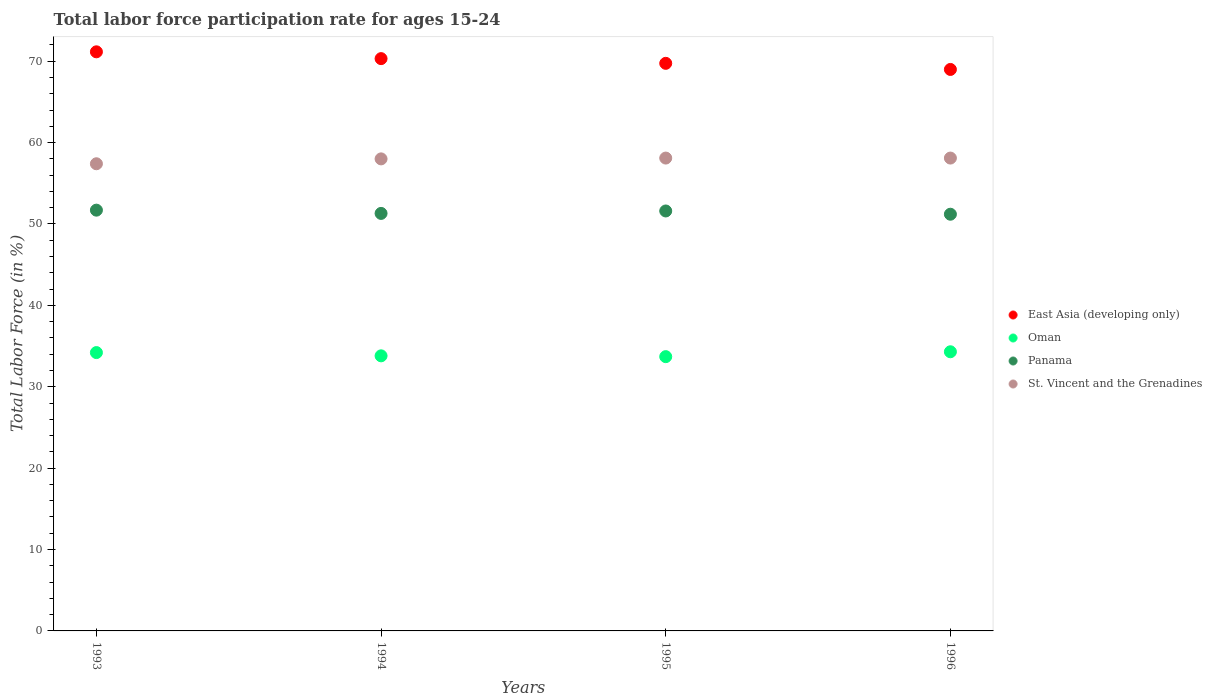Is the number of dotlines equal to the number of legend labels?
Give a very brief answer. Yes. What is the labor force participation rate in St. Vincent and the Grenadines in 1995?
Provide a short and direct response. 58.1. Across all years, what is the maximum labor force participation rate in Panama?
Make the answer very short. 51.7. Across all years, what is the minimum labor force participation rate in East Asia (developing only)?
Provide a succinct answer. 68.99. In which year was the labor force participation rate in Panama minimum?
Keep it short and to the point. 1996. What is the total labor force participation rate in East Asia (developing only) in the graph?
Make the answer very short. 280.2. What is the difference between the labor force participation rate in East Asia (developing only) in 1995 and that in 1996?
Provide a short and direct response. 0.75. What is the difference between the labor force participation rate in Panama in 1993 and the labor force participation rate in East Asia (developing only) in 1994?
Your answer should be compact. -18.62. What is the average labor force participation rate in St. Vincent and the Grenadines per year?
Your response must be concise. 57.9. In the year 1993, what is the difference between the labor force participation rate in East Asia (developing only) and labor force participation rate in Panama?
Your answer should be compact. 19.46. What is the ratio of the labor force participation rate in Panama in 1993 to that in 1996?
Offer a very short reply. 1.01. Is the difference between the labor force participation rate in East Asia (developing only) in 1995 and 1996 greater than the difference between the labor force participation rate in Panama in 1995 and 1996?
Provide a succinct answer. Yes. What is the difference between the highest and the second highest labor force participation rate in Oman?
Provide a short and direct response. 0.1. What is the difference between the highest and the lowest labor force participation rate in East Asia (developing only)?
Your answer should be very brief. 2.17. In how many years, is the labor force participation rate in East Asia (developing only) greater than the average labor force participation rate in East Asia (developing only) taken over all years?
Provide a succinct answer. 2. Is it the case that in every year, the sum of the labor force participation rate in Panama and labor force participation rate in Oman  is greater than the labor force participation rate in East Asia (developing only)?
Offer a terse response. Yes. Does the labor force participation rate in Oman monotonically increase over the years?
Offer a very short reply. No. How many years are there in the graph?
Your answer should be compact. 4. Are the values on the major ticks of Y-axis written in scientific E-notation?
Ensure brevity in your answer.  No. Does the graph contain any zero values?
Make the answer very short. No. Does the graph contain grids?
Provide a succinct answer. No. Where does the legend appear in the graph?
Keep it short and to the point. Center right. What is the title of the graph?
Offer a very short reply. Total labor force participation rate for ages 15-24. Does "Djibouti" appear as one of the legend labels in the graph?
Your answer should be compact. No. What is the label or title of the X-axis?
Your answer should be compact. Years. What is the Total Labor Force (in %) of East Asia (developing only) in 1993?
Provide a short and direct response. 71.16. What is the Total Labor Force (in %) of Oman in 1993?
Provide a short and direct response. 34.2. What is the Total Labor Force (in %) of Panama in 1993?
Provide a succinct answer. 51.7. What is the Total Labor Force (in %) in St. Vincent and the Grenadines in 1993?
Your answer should be very brief. 57.4. What is the Total Labor Force (in %) in East Asia (developing only) in 1994?
Your answer should be very brief. 70.32. What is the Total Labor Force (in %) of Oman in 1994?
Keep it short and to the point. 33.8. What is the Total Labor Force (in %) in Panama in 1994?
Your answer should be compact. 51.3. What is the Total Labor Force (in %) of St. Vincent and the Grenadines in 1994?
Your response must be concise. 58. What is the Total Labor Force (in %) of East Asia (developing only) in 1995?
Offer a very short reply. 69.74. What is the Total Labor Force (in %) of Oman in 1995?
Give a very brief answer. 33.7. What is the Total Labor Force (in %) of Panama in 1995?
Your response must be concise. 51.6. What is the Total Labor Force (in %) of St. Vincent and the Grenadines in 1995?
Provide a succinct answer. 58.1. What is the Total Labor Force (in %) of East Asia (developing only) in 1996?
Your response must be concise. 68.99. What is the Total Labor Force (in %) in Oman in 1996?
Offer a terse response. 34.3. What is the Total Labor Force (in %) in Panama in 1996?
Ensure brevity in your answer.  51.2. What is the Total Labor Force (in %) of St. Vincent and the Grenadines in 1996?
Make the answer very short. 58.1. Across all years, what is the maximum Total Labor Force (in %) of East Asia (developing only)?
Make the answer very short. 71.16. Across all years, what is the maximum Total Labor Force (in %) of Oman?
Offer a terse response. 34.3. Across all years, what is the maximum Total Labor Force (in %) of Panama?
Offer a very short reply. 51.7. Across all years, what is the maximum Total Labor Force (in %) in St. Vincent and the Grenadines?
Ensure brevity in your answer.  58.1. Across all years, what is the minimum Total Labor Force (in %) of East Asia (developing only)?
Provide a short and direct response. 68.99. Across all years, what is the minimum Total Labor Force (in %) of Oman?
Your answer should be very brief. 33.7. Across all years, what is the minimum Total Labor Force (in %) in Panama?
Your answer should be very brief. 51.2. Across all years, what is the minimum Total Labor Force (in %) of St. Vincent and the Grenadines?
Provide a short and direct response. 57.4. What is the total Total Labor Force (in %) of East Asia (developing only) in the graph?
Provide a short and direct response. 280.2. What is the total Total Labor Force (in %) in Oman in the graph?
Your answer should be very brief. 136. What is the total Total Labor Force (in %) of Panama in the graph?
Make the answer very short. 205.8. What is the total Total Labor Force (in %) of St. Vincent and the Grenadines in the graph?
Your answer should be compact. 231.6. What is the difference between the Total Labor Force (in %) of East Asia (developing only) in 1993 and that in 1994?
Offer a terse response. 0.84. What is the difference between the Total Labor Force (in %) of Oman in 1993 and that in 1994?
Provide a succinct answer. 0.4. What is the difference between the Total Labor Force (in %) in St. Vincent and the Grenadines in 1993 and that in 1994?
Your response must be concise. -0.6. What is the difference between the Total Labor Force (in %) of East Asia (developing only) in 1993 and that in 1995?
Provide a succinct answer. 1.42. What is the difference between the Total Labor Force (in %) in Oman in 1993 and that in 1995?
Make the answer very short. 0.5. What is the difference between the Total Labor Force (in %) in Panama in 1993 and that in 1995?
Offer a terse response. 0.1. What is the difference between the Total Labor Force (in %) of East Asia (developing only) in 1993 and that in 1996?
Keep it short and to the point. 2.17. What is the difference between the Total Labor Force (in %) of Panama in 1993 and that in 1996?
Your answer should be very brief. 0.5. What is the difference between the Total Labor Force (in %) in East Asia (developing only) in 1994 and that in 1995?
Provide a succinct answer. 0.58. What is the difference between the Total Labor Force (in %) of Panama in 1994 and that in 1995?
Your answer should be compact. -0.3. What is the difference between the Total Labor Force (in %) in St. Vincent and the Grenadines in 1994 and that in 1995?
Provide a short and direct response. -0.1. What is the difference between the Total Labor Force (in %) of East Asia (developing only) in 1994 and that in 1996?
Make the answer very short. 1.33. What is the difference between the Total Labor Force (in %) of Panama in 1994 and that in 1996?
Ensure brevity in your answer.  0.1. What is the difference between the Total Labor Force (in %) of St. Vincent and the Grenadines in 1994 and that in 1996?
Offer a terse response. -0.1. What is the difference between the Total Labor Force (in %) of East Asia (developing only) in 1995 and that in 1996?
Make the answer very short. 0.75. What is the difference between the Total Labor Force (in %) in Oman in 1995 and that in 1996?
Keep it short and to the point. -0.6. What is the difference between the Total Labor Force (in %) of East Asia (developing only) in 1993 and the Total Labor Force (in %) of Oman in 1994?
Provide a succinct answer. 37.36. What is the difference between the Total Labor Force (in %) of East Asia (developing only) in 1993 and the Total Labor Force (in %) of Panama in 1994?
Keep it short and to the point. 19.86. What is the difference between the Total Labor Force (in %) in East Asia (developing only) in 1993 and the Total Labor Force (in %) in St. Vincent and the Grenadines in 1994?
Your answer should be very brief. 13.16. What is the difference between the Total Labor Force (in %) of Oman in 1993 and the Total Labor Force (in %) of Panama in 1994?
Your answer should be compact. -17.1. What is the difference between the Total Labor Force (in %) of Oman in 1993 and the Total Labor Force (in %) of St. Vincent and the Grenadines in 1994?
Make the answer very short. -23.8. What is the difference between the Total Labor Force (in %) of Panama in 1993 and the Total Labor Force (in %) of St. Vincent and the Grenadines in 1994?
Ensure brevity in your answer.  -6.3. What is the difference between the Total Labor Force (in %) of East Asia (developing only) in 1993 and the Total Labor Force (in %) of Oman in 1995?
Your response must be concise. 37.46. What is the difference between the Total Labor Force (in %) of East Asia (developing only) in 1993 and the Total Labor Force (in %) of Panama in 1995?
Give a very brief answer. 19.56. What is the difference between the Total Labor Force (in %) in East Asia (developing only) in 1993 and the Total Labor Force (in %) in St. Vincent and the Grenadines in 1995?
Offer a very short reply. 13.06. What is the difference between the Total Labor Force (in %) in Oman in 1993 and the Total Labor Force (in %) in Panama in 1995?
Provide a short and direct response. -17.4. What is the difference between the Total Labor Force (in %) in Oman in 1993 and the Total Labor Force (in %) in St. Vincent and the Grenadines in 1995?
Provide a short and direct response. -23.9. What is the difference between the Total Labor Force (in %) of East Asia (developing only) in 1993 and the Total Labor Force (in %) of Oman in 1996?
Offer a very short reply. 36.86. What is the difference between the Total Labor Force (in %) in East Asia (developing only) in 1993 and the Total Labor Force (in %) in Panama in 1996?
Your response must be concise. 19.96. What is the difference between the Total Labor Force (in %) in East Asia (developing only) in 1993 and the Total Labor Force (in %) in St. Vincent and the Grenadines in 1996?
Offer a terse response. 13.06. What is the difference between the Total Labor Force (in %) in Oman in 1993 and the Total Labor Force (in %) in St. Vincent and the Grenadines in 1996?
Make the answer very short. -23.9. What is the difference between the Total Labor Force (in %) of East Asia (developing only) in 1994 and the Total Labor Force (in %) of Oman in 1995?
Keep it short and to the point. 36.62. What is the difference between the Total Labor Force (in %) of East Asia (developing only) in 1994 and the Total Labor Force (in %) of Panama in 1995?
Give a very brief answer. 18.72. What is the difference between the Total Labor Force (in %) in East Asia (developing only) in 1994 and the Total Labor Force (in %) in St. Vincent and the Grenadines in 1995?
Your response must be concise. 12.22. What is the difference between the Total Labor Force (in %) in Oman in 1994 and the Total Labor Force (in %) in Panama in 1995?
Make the answer very short. -17.8. What is the difference between the Total Labor Force (in %) of Oman in 1994 and the Total Labor Force (in %) of St. Vincent and the Grenadines in 1995?
Give a very brief answer. -24.3. What is the difference between the Total Labor Force (in %) of Panama in 1994 and the Total Labor Force (in %) of St. Vincent and the Grenadines in 1995?
Provide a succinct answer. -6.8. What is the difference between the Total Labor Force (in %) of East Asia (developing only) in 1994 and the Total Labor Force (in %) of Oman in 1996?
Keep it short and to the point. 36.02. What is the difference between the Total Labor Force (in %) in East Asia (developing only) in 1994 and the Total Labor Force (in %) in Panama in 1996?
Your response must be concise. 19.12. What is the difference between the Total Labor Force (in %) in East Asia (developing only) in 1994 and the Total Labor Force (in %) in St. Vincent and the Grenadines in 1996?
Your answer should be compact. 12.22. What is the difference between the Total Labor Force (in %) in Oman in 1994 and the Total Labor Force (in %) in Panama in 1996?
Your answer should be compact. -17.4. What is the difference between the Total Labor Force (in %) in Oman in 1994 and the Total Labor Force (in %) in St. Vincent and the Grenadines in 1996?
Offer a terse response. -24.3. What is the difference between the Total Labor Force (in %) in Panama in 1994 and the Total Labor Force (in %) in St. Vincent and the Grenadines in 1996?
Provide a short and direct response. -6.8. What is the difference between the Total Labor Force (in %) in East Asia (developing only) in 1995 and the Total Labor Force (in %) in Oman in 1996?
Make the answer very short. 35.44. What is the difference between the Total Labor Force (in %) of East Asia (developing only) in 1995 and the Total Labor Force (in %) of Panama in 1996?
Your response must be concise. 18.54. What is the difference between the Total Labor Force (in %) of East Asia (developing only) in 1995 and the Total Labor Force (in %) of St. Vincent and the Grenadines in 1996?
Make the answer very short. 11.64. What is the difference between the Total Labor Force (in %) of Oman in 1995 and the Total Labor Force (in %) of Panama in 1996?
Your response must be concise. -17.5. What is the difference between the Total Labor Force (in %) of Oman in 1995 and the Total Labor Force (in %) of St. Vincent and the Grenadines in 1996?
Make the answer very short. -24.4. What is the average Total Labor Force (in %) in East Asia (developing only) per year?
Ensure brevity in your answer.  70.05. What is the average Total Labor Force (in %) in Oman per year?
Provide a succinct answer. 34. What is the average Total Labor Force (in %) of Panama per year?
Keep it short and to the point. 51.45. What is the average Total Labor Force (in %) in St. Vincent and the Grenadines per year?
Provide a succinct answer. 57.9. In the year 1993, what is the difference between the Total Labor Force (in %) in East Asia (developing only) and Total Labor Force (in %) in Oman?
Your answer should be very brief. 36.96. In the year 1993, what is the difference between the Total Labor Force (in %) of East Asia (developing only) and Total Labor Force (in %) of Panama?
Offer a terse response. 19.46. In the year 1993, what is the difference between the Total Labor Force (in %) in East Asia (developing only) and Total Labor Force (in %) in St. Vincent and the Grenadines?
Your answer should be very brief. 13.76. In the year 1993, what is the difference between the Total Labor Force (in %) of Oman and Total Labor Force (in %) of Panama?
Ensure brevity in your answer.  -17.5. In the year 1993, what is the difference between the Total Labor Force (in %) in Oman and Total Labor Force (in %) in St. Vincent and the Grenadines?
Your answer should be very brief. -23.2. In the year 1994, what is the difference between the Total Labor Force (in %) of East Asia (developing only) and Total Labor Force (in %) of Oman?
Your answer should be very brief. 36.52. In the year 1994, what is the difference between the Total Labor Force (in %) of East Asia (developing only) and Total Labor Force (in %) of Panama?
Your response must be concise. 19.02. In the year 1994, what is the difference between the Total Labor Force (in %) in East Asia (developing only) and Total Labor Force (in %) in St. Vincent and the Grenadines?
Keep it short and to the point. 12.32. In the year 1994, what is the difference between the Total Labor Force (in %) of Oman and Total Labor Force (in %) of Panama?
Offer a terse response. -17.5. In the year 1994, what is the difference between the Total Labor Force (in %) in Oman and Total Labor Force (in %) in St. Vincent and the Grenadines?
Provide a succinct answer. -24.2. In the year 1994, what is the difference between the Total Labor Force (in %) of Panama and Total Labor Force (in %) of St. Vincent and the Grenadines?
Your answer should be very brief. -6.7. In the year 1995, what is the difference between the Total Labor Force (in %) in East Asia (developing only) and Total Labor Force (in %) in Oman?
Ensure brevity in your answer.  36.04. In the year 1995, what is the difference between the Total Labor Force (in %) in East Asia (developing only) and Total Labor Force (in %) in Panama?
Ensure brevity in your answer.  18.14. In the year 1995, what is the difference between the Total Labor Force (in %) of East Asia (developing only) and Total Labor Force (in %) of St. Vincent and the Grenadines?
Give a very brief answer. 11.64. In the year 1995, what is the difference between the Total Labor Force (in %) in Oman and Total Labor Force (in %) in Panama?
Provide a short and direct response. -17.9. In the year 1995, what is the difference between the Total Labor Force (in %) in Oman and Total Labor Force (in %) in St. Vincent and the Grenadines?
Give a very brief answer. -24.4. In the year 1995, what is the difference between the Total Labor Force (in %) in Panama and Total Labor Force (in %) in St. Vincent and the Grenadines?
Your answer should be very brief. -6.5. In the year 1996, what is the difference between the Total Labor Force (in %) in East Asia (developing only) and Total Labor Force (in %) in Oman?
Your response must be concise. 34.69. In the year 1996, what is the difference between the Total Labor Force (in %) in East Asia (developing only) and Total Labor Force (in %) in Panama?
Your response must be concise. 17.79. In the year 1996, what is the difference between the Total Labor Force (in %) in East Asia (developing only) and Total Labor Force (in %) in St. Vincent and the Grenadines?
Keep it short and to the point. 10.89. In the year 1996, what is the difference between the Total Labor Force (in %) in Oman and Total Labor Force (in %) in Panama?
Your answer should be compact. -16.9. In the year 1996, what is the difference between the Total Labor Force (in %) of Oman and Total Labor Force (in %) of St. Vincent and the Grenadines?
Provide a short and direct response. -23.8. In the year 1996, what is the difference between the Total Labor Force (in %) in Panama and Total Labor Force (in %) in St. Vincent and the Grenadines?
Make the answer very short. -6.9. What is the ratio of the Total Labor Force (in %) in East Asia (developing only) in 1993 to that in 1994?
Give a very brief answer. 1.01. What is the ratio of the Total Labor Force (in %) in Oman in 1993 to that in 1994?
Provide a short and direct response. 1.01. What is the ratio of the Total Labor Force (in %) of Panama in 1993 to that in 1994?
Provide a short and direct response. 1.01. What is the ratio of the Total Labor Force (in %) of St. Vincent and the Grenadines in 1993 to that in 1994?
Ensure brevity in your answer.  0.99. What is the ratio of the Total Labor Force (in %) of East Asia (developing only) in 1993 to that in 1995?
Make the answer very short. 1.02. What is the ratio of the Total Labor Force (in %) of Oman in 1993 to that in 1995?
Give a very brief answer. 1.01. What is the ratio of the Total Labor Force (in %) in Panama in 1993 to that in 1995?
Your answer should be very brief. 1. What is the ratio of the Total Labor Force (in %) of St. Vincent and the Grenadines in 1993 to that in 1995?
Offer a very short reply. 0.99. What is the ratio of the Total Labor Force (in %) of East Asia (developing only) in 1993 to that in 1996?
Make the answer very short. 1.03. What is the ratio of the Total Labor Force (in %) of Panama in 1993 to that in 1996?
Your response must be concise. 1.01. What is the ratio of the Total Labor Force (in %) in St. Vincent and the Grenadines in 1993 to that in 1996?
Your response must be concise. 0.99. What is the ratio of the Total Labor Force (in %) of East Asia (developing only) in 1994 to that in 1995?
Keep it short and to the point. 1.01. What is the ratio of the Total Labor Force (in %) of Oman in 1994 to that in 1995?
Provide a short and direct response. 1. What is the ratio of the Total Labor Force (in %) in St. Vincent and the Grenadines in 1994 to that in 1995?
Keep it short and to the point. 1. What is the ratio of the Total Labor Force (in %) of East Asia (developing only) in 1994 to that in 1996?
Your answer should be very brief. 1.02. What is the ratio of the Total Labor Force (in %) of Oman in 1994 to that in 1996?
Your response must be concise. 0.99. What is the ratio of the Total Labor Force (in %) of St. Vincent and the Grenadines in 1994 to that in 1996?
Give a very brief answer. 1. What is the ratio of the Total Labor Force (in %) in East Asia (developing only) in 1995 to that in 1996?
Your answer should be compact. 1.01. What is the ratio of the Total Labor Force (in %) in Oman in 1995 to that in 1996?
Your answer should be very brief. 0.98. What is the ratio of the Total Labor Force (in %) of Panama in 1995 to that in 1996?
Provide a short and direct response. 1.01. What is the ratio of the Total Labor Force (in %) of St. Vincent and the Grenadines in 1995 to that in 1996?
Make the answer very short. 1. What is the difference between the highest and the second highest Total Labor Force (in %) of East Asia (developing only)?
Your answer should be compact. 0.84. What is the difference between the highest and the second highest Total Labor Force (in %) of Oman?
Provide a succinct answer. 0.1. What is the difference between the highest and the second highest Total Labor Force (in %) in St. Vincent and the Grenadines?
Make the answer very short. 0. What is the difference between the highest and the lowest Total Labor Force (in %) of East Asia (developing only)?
Provide a short and direct response. 2.17. What is the difference between the highest and the lowest Total Labor Force (in %) of Oman?
Provide a short and direct response. 0.6. What is the difference between the highest and the lowest Total Labor Force (in %) of Panama?
Make the answer very short. 0.5. 